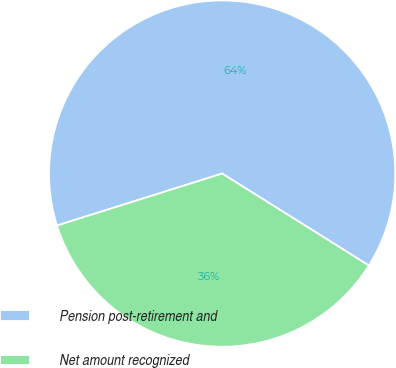<chart> <loc_0><loc_0><loc_500><loc_500><pie_chart><fcel>Pension post-retirement and<fcel>Net amount recognized<nl><fcel>63.76%<fcel>36.24%<nl></chart> 